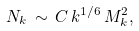Convert formula to latex. <formula><loc_0><loc_0><loc_500><loc_500>N _ { k } \, \sim \, C \, k ^ { 1 / 6 } \, M _ { k } ^ { 2 } ,</formula> 